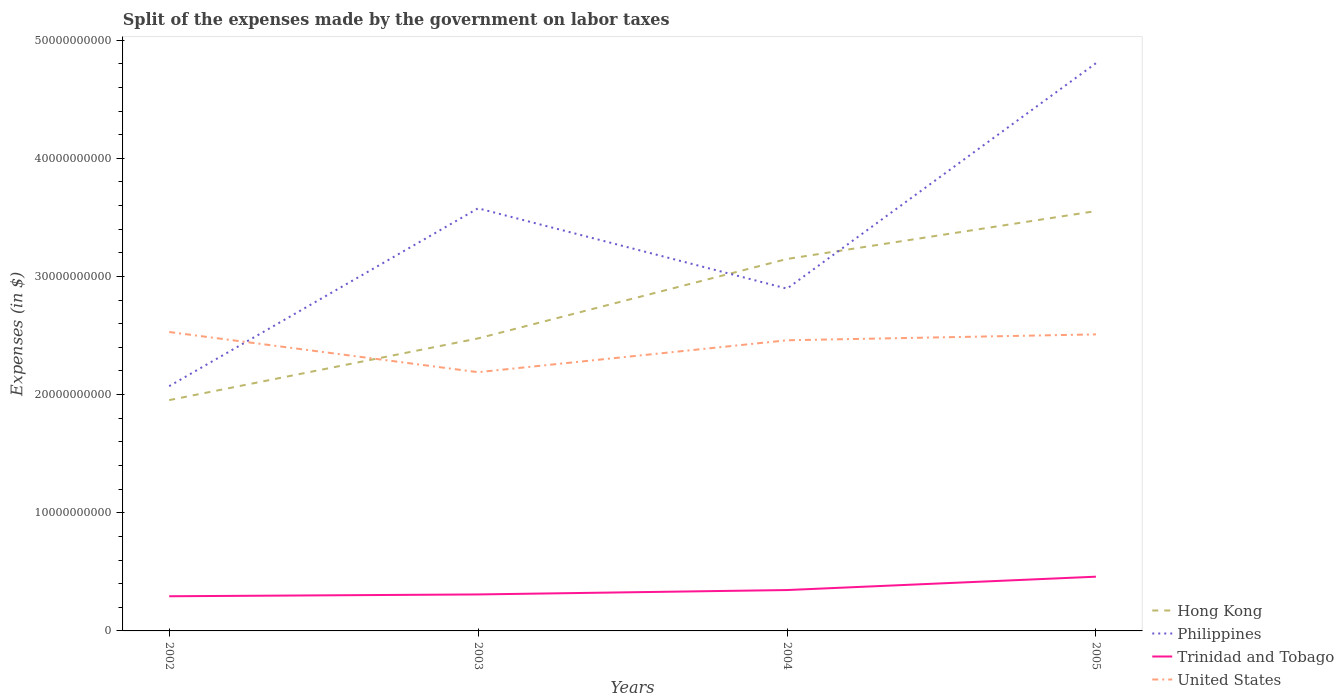Does the line corresponding to Hong Kong intersect with the line corresponding to United States?
Ensure brevity in your answer.  Yes. Across all years, what is the maximum expenses made by the government on labor taxes in United States?
Your answer should be compact. 2.19e+1. In which year was the expenses made by the government on labor taxes in Trinidad and Tobago maximum?
Give a very brief answer. 2002. What is the total expenses made by the government on labor taxes in United States in the graph?
Your answer should be compact. -3.20e+09. What is the difference between the highest and the second highest expenses made by the government on labor taxes in Philippines?
Your response must be concise. 2.73e+1. How many lines are there?
Ensure brevity in your answer.  4. How many years are there in the graph?
Give a very brief answer. 4. Does the graph contain grids?
Keep it short and to the point. No. Where does the legend appear in the graph?
Provide a short and direct response. Bottom right. How many legend labels are there?
Keep it short and to the point. 4. What is the title of the graph?
Offer a terse response. Split of the expenses made by the government on labor taxes. What is the label or title of the X-axis?
Offer a terse response. Years. What is the label or title of the Y-axis?
Your response must be concise. Expenses (in $). What is the Expenses (in $) in Hong Kong in 2002?
Provide a short and direct response. 1.95e+1. What is the Expenses (in $) in Philippines in 2002?
Offer a very short reply. 2.07e+1. What is the Expenses (in $) of Trinidad and Tobago in 2002?
Ensure brevity in your answer.  2.93e+09. What is the Expenses (in $) in United States in 2002?
Give a very brief answer. 2.53e+1. What is the Expenses (in $) of Hong Kong in 2003?
Make the answer very short. 2.48e+1. What is the Expenses (in $) in Philippines in 2003?
Provide a succinct answer. 3.58e+1. What is the Expenses (in $) in Trinidad and Tobago in 2003?
Provide a succinct answer. 3.09e+09. What is the Expenses (in $) of United States in 2003?
Your answer should be compact. 2.19e+1. What is the Expenses (in $) in Hong Kong in 2004?
Ensure brevity in your answer.  3.15e+1. What is the Expenses (in $) of Philippines in 2004?
Provide a succinct answer. 2.90e+1. What is the Expenses (in $) of Trinidad and Tobago in 2004?
Offer a terse response. 3.46e+09. What is the Expenses (in $) of United States in 2004?
Keep it short and to the point. 2.46e+1. What is the Expenses (in $) in Hong Kong in 2005?
Your response must be concise. 3.55e+1. What is the Expenses (in $) of Philippines in 2005?
Your answer should be compact. 4.80e+1. What is the Expenses (in $) in Trinidad and Tobago in 2005?
Your answer should be compact. 4.59e+09. What is the Expenses (in $) in United States in 2005?
Give a very brief answer. 2.51e+1. Across all years, what is the maximum Expenses (in $) in Hong Kong?
Offer a terse response. 3.55e+1. Across all years, what is the maximum Expenses (in $) in Philippines?
Give a very brief answer. 4.80e+1. Across all years, what is the maximum Expenses (in $) in Trinidad and Tobago?
Give a very brief answer. 4.59e+09. Across all years, what is the maximum Expenses (in $) in United States?
Your answer should be very brief. 2.53e+1. Across all years, what is the minimum Expenses (in $) in Hong Kong?
Your response must be concise. 1.95e+1. Across all years, what is the minimum Expenses (in $) of Philippines?
Offer a very short reply. 2.07e+1. Across all years, what is the minimum Expenses (in $) of Trinidad and Tobago?
Offer a terse response. 2.93e+09. Across all years, what is the minimum Expenses (in $) of United States?
Offer a very short reply. 2.19e+1. What is the total Expenses (in $) in Hong Kong in the graph?
Your response must be concise. 1.11e+11. What is the total Expenses (in $) of Philippines in the graph?
Offer a very short reply. 1.34e+11. What is the total Expenses (in $) in Trinidad and Tobago in the graph?
Offer a terse response. 1.41e+1. What is the total Expenses (in $) in United States in the graph?
Your answer should be compact. 9.69e+1. What is the difference between the Expenses (in $) of Hong Kong in 2002 and that in 2003?
Provide a succinct answer. -5.22e+09. What is the difference between the Expenses (in $) in Philippines in 2002 and that in 2003?
Give a very brief answer. -1.51e+1. What is the difference between the Expenses (in $) of Trinidad and Tobago in 2002 and that in 2003?
Your answer should be very brief. -1.53e+08. What is the difference between the Expenses (in $) of United States in 2002 and that in 2003?
Your answer should be compact. 3.40e+09. What is the difference between the Expenses (in $) in Hong Kong in 2002 and that in 2004?
Your answer should be compact. -1.19e+1. What is the difference between the Expenses (in $) of Philippines in 2002 and that in 2004?
Your response must be concise. -8.25e+09. What is the difference between the Expenses (in $) in Trinidad and Tobago in 2002 and that in 2004?
Ensure brevity in your answer.  -5.26e+08. What is the difference between the Expenses (in $) of United States in 2002 and that in 2004?
Your answer should be very brief. 7.00e+08. What is the difference between the Expenses (in $) of Hong Kong in 2002 and that in 2005?
Make the answer very short. -1.60e+1. What is the difference between the Expenses (in $) in Philippines in 2002 and that in 2005?
Provide a succinct answer. -2.73e+1. What is the difference between the Expenses (in $) of Trinidad and Tobago in 2002 and that in 2005?
Make the answer very short. -1.66e+09. What is the difference between the Expenses (in $) of Hong Kong in 2003 and that in 2004?
Offer a terse response. -6.72e+09. What is the difference between the Expenses (in $) in Philippines in 2003 and that in 2004?
Offer a terse response. 6.80e+09. What is the difference between the Expenses (in $) in Trinidad and Tobago in 2003 and that in 2004?
Offer a very short reply. -3.72e+08. What is the difference between the Expenses (in $) in United States in 2003 and that in 2004?
Make the answer very short. -2.70e+09. What is the difference between the Expenses (in $) of Hong Kong in 2003 and that in 2005?
Ensure brevity in your answer.  -1.08e+1. What is the difference between the Expenses (in $) of Philippines in 2003 and that in 2005?
Your answer should be very brief. -1.23e+1. What is the difference between the Expenses (in $) in Trinidad and Tobago in 2003 and that in 2005?
Ensure brevity in your answer.  -1.50e+09. What is the difference between the Expenses (in $) of United States in 2003 and that in 2005?
Your answer should be very brief. -3.20e+09. What is the difference between the Expenses (in $) in Hong Kong in 2004 and that in 2005?
Your answer should be very brief. -4.06e+09. What is the difference between the Expenses (in $) of Philippines in 2004 and that in 2005?
Offer a very short reply. -1.91e+1. What is the difference between the Expenses (in $) of Trinidad and Tobago in 2004 and that in 2005?
Provide a short and direct response. -1.13e+09. What is the difference between the Expenses (in $) of United States in 2004 and that in 2005?
Ensure brevity in your answer.  -5.00e+08. What is the difference between the Expenses (in $) of Hong Kong in 2002 and the Expenses (in $) of Philippines in 2003?
Provide a short and direct response. -1.62e+1. What is the difference between the Expenses (in $) in Hong Kong in 2002 and the Expenses (in $) in Trinidad and Tobago in 2003?
Give a very brief answer. 1.64e+1. What is the difference between the Expenses (in $) of Hong Kong in 2002 and the Expenses (in $) of United States in 2003?
Give a very brief answer. -2.36e+09. What is the difference between the Expenses (in $) of Philippines in 2002 and the Expenses (in $) of Trinidad and Tobago in 2003?
Make the answer very short. 1.76e+1. What is the difference between the Expenses (in $) in Philippines in 2002 and the Expenses (in $) in United States in 2003?
Your answer should be very brief. -1.18e+09. What is the difference between the Expenses (in $) in Trinidad and Tobago in 2002 and the Expenses (in $) in United States in 2003?
Give a very brief answer. -1.90e+1. What is the difference between the Expenses (in $) of Hong Kong in 2002 and the Expenses (in $) of Philippines in 2004?
Your answer should be compact. -9.43e+09. What is the difference between the Expenses (in $) of Hong Kong in 2002 and the Expenses (in $) of Trinidad and Tobago in 2004?
Your response must be concise. 1.61e+1. What is the difference between the Expenses (in $) in Hong Kong in 2002 and the Expenses (in $) in United States in 2004?
Ensure brevity in your answer.  -5.06e+09. What is the difference between the Expenses (in $) in Philippines in 2002 and the Expenses (in $) in Trinidad and Tobago in 2004?
Your response must be concise. 1.73e+1. What is the difference between the Expenses (in $) of Philippines in 2002 and the Expenses (in $) of United States in 2004?
Make the answer very short. -3.88e+09. What is the difference between the Expenses (in $) of Trinidad and Tobago in 2002 and the Expenses (in $) of United States in 2004?
Offer a terse response. -2.17e+1. What is the difference between the Expenses (in $) in Hong Kong in 2002 and the Expenses (in $) in Philippines in 2005?
Your response must be concise. -2.85e+1. What is the difference between the Expenses (in $) of Hong Kong in 2002 and the Expenses (in $) of Trinidad and Tobago in 2005?
Offer a terse response. 1.49e+1. What is the difference between the Expenses (in $) in Hong Kong in 2002 and the Expenses (in $) in United States in 2005?
Your answer should be very brief. -5.56e+09. What is the difference between the Expenses (in $) in Philippines in 2002 and the Expenses (in $) in Trinidad and Tobago in 2005?
Offer a terse response. 1.61e+1. What is the difference between the Expenses (in $) of Philippines in 2002 and the Expenses (in $) of United States in 2005?
Ensure brevity in your answer.  -4.38e+09. What is the difference between the Expenses (in $) of Trinidad and Tobago in 2002 and the Expenses (in $) of United States in 2005?
Offer a terse response. -2.22e+1. What is the difference between the Expenses (in $) in Hong Kong in 2003 and the Expenses (in $) in Philippines in 2004?
Offer a terse response. -4.21e+09. What is the difference between the Expenses (in $) of Hong Kong in 2003 and the Expenses (in $) of Trinidad and Tobago in 2004?
Keep it short and to the point. 2.13e+1. What is the difference between the Expenses (in $) in Hong Kong in 2003 and the Expenses (in $) in United States in 2004?
Make the answer very short. 1.60e+08. What is the difference between the Expenses (in $) in Philippines in 2003 and the Expenses (in $) in Trinidad and Tobago in 2004?
Provide a succinct answer. 3.23e+1. What is the difference between the Expenses (in $) in Philippines in 2003 and the Expenses (in $) in United States in 2004?
Provide a short and direct response. 1.12e+1. What is the difference between the Expenses (in $) in Trinidad and Tobago in 2003 and the Expenses (in $) in United States in 2004?
Your response must be concise. -2.15e+1. What is the difference between the Expenses (in $) of Hong Kong in 2003 and the Expenses (in $) of Philippines in 2005?
Ensure brevity in your answer.  -2.33e+1. What is the difference between the Expenses (in $) in Hong Kong in 2003 and the Expenses (in $) in Trinidad and Tobago in 2005?
Your answer should be very brief. 2.02e+1. What is the difference between the Expenses (in $) in Hong Kong in 2003 and the Expenses (in $) in United States in 2005?
Ensure brevity in your answer.  -3.40e+08. What is the difference between the Expenses (in $) in Philippines in 2003 and the Expenses (in $) in Trinidad and Tobago in 2005?
Give a very brief answer. 3.12e+1. What is the difference between the Expenses (in $) in Philippines in 2003 and the Expenses (in $) in United States in 2005?
Your answer should be very brief. 1.07e+1. What is the difference between the Expenses (in $) in Trinidad and Tobago in 2003 and the Expenses (in $) in United States in 2005?
Offer a terse response. -2.20e+1. What is the difference between the Expenses (in $) in Hong Kong in 2004 and the Expenses (in $) in Philippines in 2005?
Your answer should be compact. -1.66e+1. What is the difference between the Expenses (in $) in Hong Kong in 2004 and the Expenses (in $) in Trinidad and Tobago in 2005?
Your answer should be compact. 2.69e+1. What is the difference between the Expenses (in $) in Hong Kong in 2004 and the Expenses (in $) in United States in 2005?
Ensure brevity in your answer.  6.38e+09. What is the difference between the Expenses (in $) of Philippines in 2004 and the Expenses (in $) of Trinidad and Tobago in 2005?
Provide a short and direct response. 2.44e+1. What is the difference between the Expenses (in $) in Philippines in 2004 and the Expenses (in $) in United States in 2005?
Offer a terse response. 3.87e+09. What is the difference between the Expenses (in $) in Trinidad and Tobago in 2004 and the Expenses (in $) in United States in 2005?
Provide a short and direct response. -2.16e+1. What is the average Expenses (in $) in Hong Kong per year?
Offer a terse response. 2.78e+1. What is the average Expenses (in $) of Philippines per year?
Ensure brevity in your answer.  3.34e+1. What is the average Expenses (in $) in Trinidad and Tobago per year?
Give a very brief answer. 3.52e+09. What is the average Expenses (in $) of United States per year?
Offer a terse response. 2.42e+1. In the year 2002, what is the difference between the Expenses (in $) of Hong Kong and Expenses (in $) of Philippines?
Give a very brief answer. -1.18e+09. In the year 2002, what is the difference between the Expenses (in $) of Hong Kong and Expenses (in $) of Trinidad and Tobago?
Your answer should be compact. 1.66e+1. In the year 2002, what is the difference between the Expenses (in $) of Hong Kong and Expenses (in $) of United States?
Ensure brevity in your answer.  -5.76e+09. In the year 2002, what is the difference between the Expenses (in $) in Philippines and Expenses (in $) in Trinidad and Tobago?
Give a very brief answer. 1.78e+1. In the year 2002, what is the difference between the Expenses (in $) of Philippines and Expenses (in $) of United States?
Your answer should be very brief. -4.58e+09. In the year 2002, what is the difference between the Expenses (in $) of Trinidad and Tobago and Expenses (in $) of United States?
Your answer should be compact. -2.24e+1. In the year 2003, what is the difference between the Expenses (in $) of Hong Kong and Expenses (in $) of Philippines?
Your answer should be compact. -1.10e+1. In the year 2003, what is the difference between the Expenses (in $) in Hong Kong and Expenses (in $) in Trinidad and Tobago?
Your response must be concise. 2.17e+1. In the year 2003, what is the difference between the Expenses (in $) of Hong Kong and Expenses (in $) of United States?
Make the answer very short. 2.86e+09. In the year 2003, what is the difference between the Expenses (in $) of Philippines and Expenses (in $) of Trinidad and Tobago?
Offer a terse response. 3.27e+1. In the year 2003, what is the difference between the Expenses (in $) in Philippines and Expenses (in $) in United States?
Your answer should be very brief. 1.39e+1. In the year 2003, what is the difference between the Expenses (in $) of Trinidad and Tobago and Expenses (in $) of United States?
Your response must be concise. -1.88e+1. In the year 2004, what is the difference between the Expenses (in $) in Hong Kong and Expenses (in $) in Philippines?
Provide a succinct answer. 2.51e+09. In the year 2004, what is the difference between the Expenses (in $) of Hong Kong and Expenses (in $) of Trinidad and Tobago?
Your answer should be very brief. 2.80e+1. In the year 2004, what is the difference between the Expenses (in $) in Hong Kong and Expenses (in $) in United States?
Your answer should be compact. 6.88e+09. In the year 2004, what is the difference between the Expenses (in $) of Philippines and Expenses (in $) of Trinidad and Tobago?
Provide a succinct answer. 2.55e+1. In the year 2004, what is the difference between the Expenses (in $) in Philippines and Expenses (in $) in United States?
Your answer should be compact. 4.37e+09. In the year 2004, what is the difference between the Expenses (in $) in Trinidad and Tobago and Expenses (in $) in United States?
Ensure brevity in your answer.  -2.11e+1. In the year 2005, what is the difference between the Expenses (in $) of Hong Kong and Expenses (in $) of Philippines?
Your response must be concise. -1.25e+1. In the year 2005, what is the difference between the Expenses (in $) of Hong Kong and Expenses (in $) of Trinidad and Tobago?
Offer a very short reply. 3.09e+1. In the year 2005, what is the difference between the Expenses (in $) of Hong Kong and Expenses (in $) of United States?
Ensure brevity in your answer.  1.04e+1. In the year 2005, what is the difference between the Expenses (in $) in Philippines and Expenses (in $) in Trinidad and Tobago?
Provide a short and direct response. 4.35e+1. In the year 2005, what is the difference between the Expenses (in $) of Philippines and Expenses (in $) of United States?
Provide a short and direct response. 2.30e+1. In the year 2005, what is the difference between the Expenses (in $) of Trinidad and Tobago and Expenses (in $) of United States?
Your response must be concise. -2.05e+1. What is the ratio of the Expenses (in $) in Hong Kong in 2002 to that in 2003?
Provide a short and direct response. 0.79. What is the ratio of the Expenses (in $) of Philippines in 2002 to that in 2003?
Keep it short and to the point. 0.58. What is the ratio of the Expenses (in $) of Trinidad and Tobago in 2002 to that in 2003?
Provide a short and direct response. 0.95. What is the ratio of the Expenses (in $) in United States in 2002 to that in 2003?
Your answer should be very brief. 1.16. What is the ratio of the Expenses (in $) of Hong Kong in 2002 to that in 2004?
Give a very brief answer. 0.62. What is the ratio of the Expenses (in $) in Philippines in 2002 to that in 2004?
Provide a succinct answer. 0.72. What is the ratio of the Expenses (in $) of Trinidad and Tobago in 2002 to that in 2004?
Offer a terse response. 0.85. What is the ratio of the Expenses (in $) of United States in 2002 to that in 2004?
Ensure brevity in your answer.  1.03. What is the ratio of the Expenses (in $) in Hong Kong in 2002 to that in 2005?
Provide a succinct answer. 0.55. What is the ratio of the Expenses (in $) in Philippines in 2002 to that in 2005?
Offer a very short reply. 0.43. What is the ratio of the Expenses (in $) of Trinidad and Tobago in 2002 to that in 2005?
Ensure brevity in your answer.  0.64. What is the ratio of the Expenses (in $) in United States in 2002 to that in 2005?
Offer a terse response. 1.01. What is the ratio of the Expenses (in $) of Hong Kong in 2003 to that in 2004?
Your answer should be very brief. 0.79. What is the ratio of the Expenses (in $) of Philippines in 2003 to that in 2004?
Your answer should be very brief. 1.23. What is the ratio of the Expenses (in $) of Trinidad and Tobago in 2003 to that in 2004?
Offer a very short reply. 0.89. What is the ratio of the Expenses (in $) of United States in 2003 to that in 2004?
Offer a very short reply. 0.89. What is the ratio of the Expenses (in $) of Hong Kong in 2003 to that in 2005?
Offer a very short reply. 0.7. What is the ratio of the Expenses (in $) in Philippines in 2003 to that in 2005?
Offer a very short reply. 0.74. What is the ratio of the Expenses (in $) in Trinidad and Tobago in 2003 to that in 2005?
Keep it short and to the point. 0.67. What is the ratio of the Expenses (in $) of United States in 2003 to that in 2005?
Provide a succinct answer. 0.87. What is the ratio of the Expenses (in $) in Hong Kong in 2004 to that in 2005?
Your response must be concise. 0.89. What is the ratio of the Expenses (in $) of Philippines in 2004 to that in 2005?
Keep it short and to the point. 0.6. What is the ratio of the Expenses (in $) of Trinidad and Tobago in 2004 to that in 2005?
Your answer should be very brief. 0.75. What is the ratio of the Expenses (in $) of United States in 2004 to that in 2005?
Make the answer very short. 0.98. What is the difference between the highest and the second highest Expenses (in $) in Hong Kong?
Provide a succinct answer. 4.06e+09. What is the difference between the highest and the second highest Expenses (in $) of Philippines?
Keep it short and to the point. 1.23e+1. What is the difference between the highest and the second highest Expenses (in $) in Trinidad and Tobago?
Your answer should be very brief. 1.13e+09. What is the difference between the highest and the lowest Expenses (in $) of Hong Kong?
Offer a terse response. 1.60e+1. What is the difference between the highest and the lowest Expenses (in $) of Philippines?
Offer a terse response. 2.73e+1. What is the difference between the highest and the lowest Expenses (in $) in Trinidad and Tobago?
Keep it short and to the point. 1.66e+09. What is the difference between the highest and the lowest Expenses (in $) of United States?
Provide a short and direct response. 3.40e+09. 